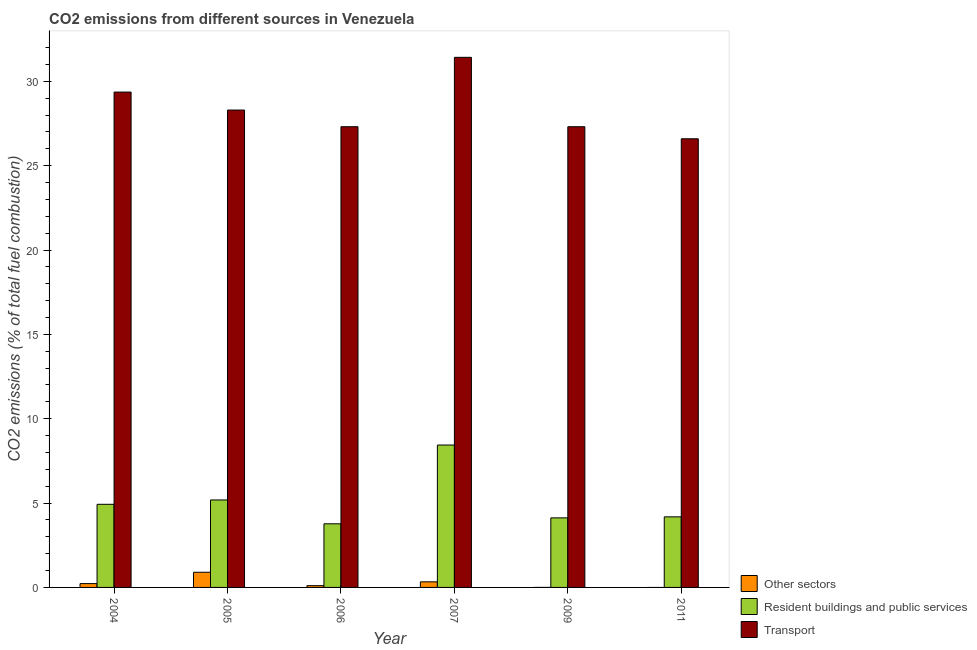How many different coloured bars are there?
Your answer should be compact. 3. How many groups of bars are there?
Offer a terse response. 6. Are the number of bars per tick equal to the number of legend labels?
Your answer should be compact. No. How many bars are there on the 6th tick from the left?
Ensure brevity in your answer.  2. How many bars are there on the 3rd tick from the right?
Make the answer very short. 3. What is the label of the 4th group of bars from the left?
Offer a very short reply. 2007. What is the percentage of co2 emissions from transport in 2004?
Keep it short and to the point. 29.36. Across all years, what is the maximum percentage of co2 emissions from resident buildings and public services?
Offer a very short reply. 8.44. Across all years, what is the minimum percentage of co2 emissions from transport?
Your response must be concise. 26.59. What is the total percentage of co2 emissions from resident buildings and public services in the graph?
Provide a short and direct response. 30.63. What is the difference between the percentage of co2 emissions from resident buildings and public services in 2007 and that in 2009?
Ensure brevity in your answer.  4.32. What is the difference between the percentage of co2 emissions from transport in 2009 and the percentage of co2 emissions from other sectors in 2004?
Provide a short and direct response. -2.05. What is the average percentage of co2 emissions from transport per year?
Keep it short and to the point. 28.38. In the year 2009, what is the difference between the percentage of co2 emissions from resident buildings and public services and percentage of co2 emissions from other sectors?
Provide a short and direct response. 0. What is the ratio of the percentage of co2 emissions from resident buildings and public services in 2005 to that in 2007?
Provide a succinct answer. 0.61. Is the difference between the percentage of co2 emissions from resident buildings and public services in 2007 and 2011 greater than the difference between the percentage of co2 emissions from transport in 2007 and 2011?
Your answer should be very brief. No. What is the difference between the highest and the second highest percentage of co2 emissions from transport?
Give a very brief answer. 2.06. What is the difference between the highest and the lowest percentage of co2 emissions from transport?
Offer a terse response. 4.83. In how many years, is the percentage of co2 emissions from other sectors greater than the average percentage of co2 emissions from other sectors taken over all years?
Your response must be concise. 2. Is it the case that in every year, the sum of the percentage of co2 emissions from other sectors and percentage of co2 emissions from resident buildings and public services is greater than the percentage of co2 emissions from transport?
Your answer should be compact. No. What is the difference between two consecutive major ticks on the Y-axis?
Offer a very short reply. 5. Does the graph contain grids?
Your answer should be very brief. No. Where does the legend appear in the graph?
Give a very brief answer. Bottom right. What is the title of the graph?
Give a very brief answer. CO2 emissions from different sources in Venezuela. Does "Unpaid family workers" appear as one of the legend labels in the graph?
Make the answer very short. No. What is the label or title of the X-axis?
Your response must be concise. Year. What is the label or title of the Y-axis?
Offer a very short reply. CO2 emissions (% of total fuel combustion). What is the CO2 emissions (% of total fuel combustion) in Other sectors in 2004?
Your answer should be very brief. 0.23. What is the CO2 emissions (% of total fuel combustion) of Resident buildings and public services in 2004?
Offer a very short reply. 4.93. What is the CO2 emissions (% of total fuel combustion) in Transport in 2004?
Offer a terse response. 29.36. What is the CO2 emissions (% of total fuel combustion) in Other sectors in 2005?
Your answer should be compact. 0.9. What is the CO2 emissions (% of total fuel combustion) in Resident buildings and public services in 2005?
Your answer should be compact. 5.18. What is the CO2 emissions (% of total fuel combustion) in Transport in 2005?
Keep it short and to the point. 28.3. What is the CO2 emissions (% of total fuel combustion) of Other sectors in 2006?
Your answer should be compact. 0.1. What is the CO2 emissions (% of total fuel combustion) of Resident buildings and public services in 2006?
Give a very brief answer. 3.77. What is the CO2 emissions (% of total fuel combustion) in Transport in 2006?
Provide a short and direct response. 27.31. What is the CO2 emissions (% of total fuel combustion) in Other sectors in 2007?
Provide a succinct answer. 0.33. What is the CO2 emissions (% of total fuel combustion) in Resident buildings and public services in 2007?
Provide a succinct answer. 8.44. What is the CO2 emissions (% of total fuel combustion) in Transport in 2007?
Your response must be concise. 31.42. What is the CO2 emissions (% of total fuel combustion) in Resident buildings and public services in 2009?
Give a very brief answer. 4.12. What is the CO2 emissions (% of total fuel combustion) of Transport in 2009?
Provide a succinct answer. 27.31. What is the CO2 emissions (% of total fuel combustion) in Other sectors in 2011?
Provide a short and direct response. 0. What is the CO2 emissions (% of total fuel combustion) in Resident buildings and public services in 2011?
Give a very brief answer. 4.18. What is the CO2 emissions (% of total fuel combustion) of Transport in 2011?
Keep it short and to the point. 26.59. Across all years, what is the maximum CO2 emissions (% of total fuel combustion) of Other sectors?
Give a very brief answer. 0.9. Across all years, what is the maximum CO2 emissions (% of total fuel combustion) in Resident buildings and public services?
Your answer should be very brief. 8.44. Across all years, what is the maximum CO2 emissions (% of total fuel combustion) of Transport?
Ensure brevity in your answer.  31.42. Across all years, what is the minimum CO2 emissions (% of total fuel combustion) in Resident buildings and public services?
Make the answer very short. 3.77. Across all years, what is the minimum CO2 emissions (% of total fuel combustion) of Transport?
Offer a terse response. 26.59. What is the total CO2 emissions (% of total fuel combustion) in Other sectors in the graph?
Your response must be concise. 1.56. What is the total CO2 emissions (% of total fuel combustion) of Resident buildings and public services in the graph?
Your response must be concise. 30.63. What is the total CO2 emissions (% of total fuel combustion) in Transport in the graph?
Keep it short and to the point. 170.29. What is the difference between the CO2 emissions (% of total fuel combustion) of Other sectors in 2004 and that in 2005?
Your answer should be very brief. -0.67. What is the difference between the CO2 emissions (% of total fuel combustion) in Resident buildings and public services in 2004 and that in 2005?
Your response must be concise. -0.26. What is the difference between the CO2 emissions (% of total fuel combustion) of Transport in 2004 and that in 2005?
Provide a succinct answer. 1.07. What is the difference between the CO2 emissions (% of total fuel combustion) in Other sectors in 2004 and that in 2006?
Make the answer very short. 0.12. What is the difference between the CO2 emissions (% of total fuel combustion) of Resident buildings and public services in 2004 and that in 2006?
Provide a succinct answer. 1.16. What is the difference between the CO2 emissions (% of total fuel combustion) of Transport in 2004 and that in 2006?
Provide a short and direct response. 2.05. What is the difference between the CO2 emissions (% of total fuel combustion) in Other sectors in 2004 and that in 2007?
Keep it short and to the point. -0.1. What is the difference between the CO2 emissions (% of total fuel combustion) of Resident buildings and public services in 2004 and that in 2007?
Offer a very short reply. -3.51. What is the difference between the CO2 emissions (% of total fuel combustion) of Transport in 2004 and that in 2007?
Ensure brevity in your answer.  -2.06. What is the difference between the CO2 emissions (% of total fuel combustion) in Resident buildings and public services in 2004 and that in 2009?
Your answer should be very brief. 0.8. What is the difference between the CO2 emissions (% of total fuel combustion) of Transport in 2004 and that in 2009?
Make the answer very short. 2.05. What is the difference between the CO2 emissions (% of total fuel combustion) of Resident buildings and public services in 2004 and that in 2011?
Offer a very short reply. 0.74. What is the difference between the CO2 emissions (% of total fuel combustion) of Transport in 2004 and that in 2011?
Your answer should be compact. 2.77. What is the difference between the CO2 emissions (% of total fuel combustion) in Other sectors in 2005 and that in 2006?
Provide a succinct answer. 0.8. What is the difference between the CO2 emissions (% of total fuel combustion) in Resident buildings and public services in 2005 and that in 2006?
Offer a terse response. 1.41. What is the difference between the CO2 emissions (% of total fuel combustion) in Transport in 2005 and that in 2006?
Provide a short and direct response. 0.99. What is the difference between the CO2 emissions (% of total fuel combustion) of Other sectors in 2005 and that in 2007?
Offer a very short reply. 0.57. What is the difference between the CO2 emissions (% of total fuel combustion) in Resident buildings and public services in 2005 and that in 2007?
Your answer should be compact. -3.26. What is the difference between the CO2 emissions (% of total fuel combustion) of Transport in 2005 and that in 2007?
Offer a very short reply. -3.13. What is the difference between the CO2 emissions (% of total fuel combustion) in Resident buildings and public services in 2005 and that in 2009?
Provide a short and direct response. 1.06. What is the difference between the CO2 emissions (% of total fuel combustion) in Transport in 2005 and that in 2009?
Your answer should be compact. 0.99. What is the difference between the CO2 emissions (% of total fuel combustion) in Transport in 2005 and that in 2011?
Provide a short and direct response. 1.7. What is the difference between the CO2 emissions (% of total fuel combustion) in Other sectors in 2006 and that in 2007?
Keep it short and to the point. -0.23. What is the difference between the CO2 emissions (% of total fuel combustion) of Resident buildings and public services in 2006 and that in 2007?
Ensure brevity in your answer.  -4.67. What is the difference between the CO2 emissions (% of total fuel combustion) in Transport in 2006 and that in 2007?
Make the answer very short. -4.11. What is the difference between the CO2 emissions (% of total fuel combustion) in Resident buildings and public services in 2006 and that in 2009?
Offer a terse response. -0.35. What is the difference between the CO2 emissions (% of total fuel combustion) of Transport in 2006 and that in 2009?
Offer a terse response. 0. What is the difference between the CO2 emissions (% of total fuel combustion) of Resident buildings and public services in 2006 and that in 2011?
Your answer should be compact. -0.41. What is the difference between the CO2 emissions (% of total fuel combustion) in Transport in 2006 and that in 2011?
Give a very brief answer. 0.71. What is the difference between the CO2 emissions (% of total fuel combustion) in Resident buildings and public services in 2007 and that in 2009?
Provide a succinct answer. 4.32. What is the difference between the CO2 emissions (% of total fuel combustion) of Transport in 2007 and that in 2009?
Offer a very short reply. 4.11. What is the difference between the CO2 emissions (% of total fuel combustion) of Resident buildings and public services in 2007 and that in 2011?
Give a very brief answer. 4.26. What is the difference between the CO2 emissions (% of total fuel combustion) in Transport in 2007 and that in 2011?
Offer a very short reply. 4.83. What is the difference between the CO2 emissions (% of total fuel combustion) of Resident buildings and public services in 2009 and that in 2011?
Offer a very short reply. -0.06. What is the difference between the CO2 emissions (% of total fuel combustion) of Transport in 2009 and that in 2011?
Provide a succinct answer. 0.71. What is the difference between the CO2 emissions (% of total fuel combustion) in Other sectors in 2004 and the CO2 emissions (% of total fuel combustion) in Resident buildings and public services in 2005?
Ensure brevity in your answer.  -4.96. What is the difference between the CO2 emissions (% of total fuel combustion) of Other sectors in 2004 and the CO2 emissions (% of total fuel combustion) of Transport in 2005?
Your answer should be very brief. -28.07. What is the difference between the CO2 emissions (% of total fuel combustion) of Resident buildings and public services in 2004 and the CO2 emissions (% of total fuel combustion) of Transport in 2005?
Offer a terse response. -23.37. What is the difference between the CO2 emissions (% of total fuel combustion) in Other sectors in 2004 and the CO2 emissions (% of total fuel combustion) in Resident buildings and public services in 2006?
Offer a terse response. -3.54. What is the difference between the CO2 emissions (% of total fuel combustion) in Other sectors in 2004 and the CO2 emissions (% of total fuel combustion) in Transport in 2006?
Provide a short and direct response. -27.08. What is the difference between the CO2 emissions (% of total fuel combustion) in Resident buildings and public services in 2004 and the CO2 emissions (% of total fuel combustion) in Transport in 2006?
Your response must be concise. -22.38. What is the difference between the CO2 emissions (% of total fuel combustion) of Other sectors in 2004 and the CO2 emissions (% of total fuel combustion) of Resident buildings and public services in 2007?
Ensure brevity in your answer.  -8.21. What is the difference between the CO2 emissions (% of total fuel combustion) of Other sectors in 2004 and the CO2 emissions (% of total fuel combustion) of Transport in 2007?
Keep it short and to the point. -31.19. What is the difference between the CO2 emissions (% of total fuel combustion) in Resident buildings and public services in 2004 and the CO2 emissions (% of total fuel combustion) in Transport in 2007?
Your answer should be very brief. -26.49. What is the difference between the CO2 emissions (% of total fuel combustion) of Other sectors in 2004 and the CO2 emissions (% of total fuel combustion) of Resident buildings and public services in 2009?
Your answer should be compact. -3.9. What is the difference between the CO2 emissions (% of total fuel combustion) in Other sectors in 2004 and the CO2 emissions (% of total fuel combustion) in Transport in 2009?
Make the answer very short. -27.08. What is the difference between the CO2 emissions (% of total fuel combustion) of Resident buildings and public services in 2004 and the CO2 emissions (% of total fuel combustion) of Transport in 2009?
Your answer should be compact. -22.38. What is the difference between the CO2 emissions (% of total fuel combustion) of Other sectors in 2004 and the CO2 emissions (% of total fuel combustion) of Resident buildings and public services in 2011?
Provide a succinct answer. -3.96. What is the difference between the CO2 emissions (% of total fuel combustion) in Other sectors in 2004 and the CO2 emissions (% of total fuel combustion) in Transport in 2011?
Give a very brief answer. -26.37. What is the difference between the CO2 emissions (% of total fuel combustion) in Resident buildings and public services in 2004 and the CO2 emissions (% of total fuel combustion) in Transport in 2011?
Provide a short and direct response. -21.67. What is the difference between the CO2 emissions (% of total fuel combustion) of Other sectors in 2005 and the CO2 emissions (% of total fuel combustion) of Resident buildings and public services in 2006?
Ensure brevity in your answer.  -2.87. What is the difference between the CO2 emissions (% of total fuel combustion) of Other sectors in 2005 and the CO2 emissions (% of total fuel combustion) of Transport in 2006?
Provide a short and direct response. -26.41. What is the difference between the CO2 emissions (% of total fuel combustion) of Resident buildings and public services in 2005 and the CO2 emissions (% of total fuel combustion) of Transport in 2006?
Your answer should be compact. -22.12. What is the difference between the CO2 emissions (% of total fuel combustion) of Other sectors in 2005 and the CO2 emissions (% of total fuel combustion) of Resident buildings and public services in 2007?
Your answer should be very brief. -7.54. What is the difference between the CO2 emissions (% of total fuel combustion) of Other sectors in 2005 and the CO2 emissions (% of total fuel combustion) of Transport in 2007?
Your answer should be very brief. -30.52. What is the difference between the CO2 emissions (% of total fuel combustion) of Resident buildings and public services in 2005 and the CO2 emissions (% of total fuel combustion) of Transport in 2007?
Make the answer very short. -26.24. What is the difference between the CO2 emissions (% of total fuel combustion) in Other sectors in 2005 and the CO2 emissions (% of total fuel combustion) in Resident buildings and public services in 2009?
Offer a very short reply. -3.22. What is the difference between the CO2 emissions (% of total fuel combustion) of Other sectors in 2005 and the CO2 emissions (% of total fuel combustion) of Transport in 2009?
Offer a very short reply. -26.41. What is the difference between the CO2 emissions (% of total fuel combustion) in Resident buildings and public services in 2005 and the CO2 emissions (% of total fuel combustion) in Transport in 2009?
Provide a succinct answer. -22.12. What is the difference between the CO2 emissions (% of total fuel combustion) of Other sectors in 2005 and the CO2 emissions (% of total fuel combustion) of Resident buildings and public services in 2011?
Provide a short and direct response. -3.28. What is the difference between the CO2 emissions (% of total fuel combustion) of Other sectors in 2005 and the CO2 emissions (% of total fuel combustion) of Transport in 2011?
Your answer should be very brief. -25.69. What is the difference between the CO2 emissions (% of total fuel combustion) in Resident buildings and public services in 2005 and the CO2 emissions (% of total fuel combustion) in Transport in 2011?
Offer a terse response. -21.41. What is the difference between the CO2 emissions (% of total fuel combustion) in Other sectors in 2006 and the CO2 emissions (% of total fuel combustion) in Resident buildings and public services in 2007?
Your response must be concise. -8.34. What is the difference between the CO2 emissions (% of total fuel combustion) in Other sectors in 2006 and the CO2 emissions (% of total fuel combustion) in Transport in 2007?
Your answer should be very brief. -31.32. What is the difference between the CO2 emissions (% of total fuel combustion) of Resident buildings and public services in 2006 and the CO2 emissions (% of total fuel combustion) of Transport in 2007?
Your answer should be very brief. -27.65. What is the difference between the CO2 emissions (% of total fuel combustion) in Other sectors in 2006 and the CO2 emissions (% of total fuel combustion) in Resident buildings and public services in 2009?
Provide a short and direct response. -4.02. What is the difference between the CO2 emissions (% of total fuel combustion) of Other sectors in 2006 and the CO2 emissions (% of total fuel combustion) of Transport in 2009?
Keep it short and to the point. -27.2. What is the difference between the CO2 emissions (% of total fuel combustion) of Resident buildings and public services in 2006 and the CO2 emissions (% of total fuel combustion) of Transport in 2009?
Offer a terse response. -23.54. What is the difference between the CO2 emissions (% of total fuel combustion) of Other sectors in 2006 and the CO2 emissions (% of total fuel combustion) of Resident buildings and public services in 2011?
Keep it short and to the point. -4.08. What is the difference between the CO2 emissions (% of total fuel combustion) in Other sectors in 2006 and the CO2 emissions (% of total fuel combustion) in Transport in 2011?
Give a very brief answer. -26.49. What is the difference between the CO2 emissions (% of total fuel combustion) of Resident buildings and public services in 2006 and the CO2 emissions (% of total fuel combustion) of Transport in 2011?
Offer a terse response. -22.82. What is the difference between the CO2 emissions (% of total fuel combustion) in Other sectors in 2007 and the CO2 emissions (% of total fuel combustion) in Resident buildings and public services in 2009?
Make the answer very short. -3.79. What is the difference between the CO2 emissions (% of total fuel combustion) of Other sectors in 2007 and the CO2 emissions (% of total fuel combustion) of Transport in 2009?
Your answer should be compact. -26.98. What is the difference between the CO2 emissions (% of total fuel combustion) in Resident buildings and public services in 2007 and the CO2 emissions (% of total fuel combustion) in Transport in 2009?
Your answer should be very brief. -18.87. What is the difference between the CO2 emissions (% of total fuel combustion) of Other sectors in 2007 and the CO2 emissions (% of total fuel combustion) of Resident buildings and public services in 2011?
Keep it short and to the point. -3.85. What is the difference between the CO2 emissions (% of total fuel combustion) of Other sectors in 2007 and the CO2 emissions (% of total fuel combustion) of Transport in 2011?
Provide a succinct answer. -26.26. What is the difference between the CO2 emissions (% of total fuel combustion) in Resident buildings and public services in 2007 and the CO2 emissions (% of total fuel combustion) in Transport in 2011?
Make the answer very short. -18.15. What is the difference between the CO2 emissions (% of total fuel combustion) of Resident buildings and public services in 2009 and the CO2 emissions (% of total fuel combustion) of Transport in 2011?
Ensure brevity in your answer.  -22.47. What is the average CO2 emissions (% of total fuel combustion) of Other sectors per year?
Your answer should be very brief. 0.26. What is the average CO2 emissions (% of total fuel combustion) of Resident buildings and public services per year?
Offer a terse response. 5.11. What is the average CO2 emissions (% of total fuel combustion) of Transport per year?
Give a very brief answer. 28.38. In the year 2004, what is the difference between the CO2 emissions (% of total fuel combustion) in Other sectors and CO2 emissions (% of total fuel combustion) in Resident buildings and public services?
Provide a short and direct response. -4.7. In the year 2004, what is the difference between the CO2 emissions (% of total fuel combustion) of Other sectors and CO2 emissions (% of total fuel combustion) of Transport?
Ensure brevity in your answer.  -29.13. In the year 2004, what is the difference between the CO2 emissions (% of total fuel combustion) in Resident buildings and public services and CO2 emissions (% of total fuel combustion) in Transport?
Ensure brevity in your answer.  -24.43. In the year 2005, what is the difference between the CO2 emissions (% of total fuel combustion) in Other sectors and CO2 emissions (% of total fuel combustion) in Resident buildings and public services?
Your answer should be very brief. -4.29. In the year 2005, what is the difference between the CO2 emissions (% of total fuel combustion) in Other sectors and CO2 emissions (% of total fuel combustion) in Transport?
Your answer should be compact. -27.4. In the year 2005, what is the difference between the CO2 emissions (% of total fuel combustion) in Resident buildings and public services and CO2 emissions (% of total fuel combustion) in Transport?
Give a very brief answer. -23.11. In the year 2006, what is the difference between the CO2 emissions (% of total fuel combustion) in Other sectors and CO2 emissions (% of total fuel combustion) in Resident buildings and public services?
Provide a short and direct response. -3.67. In the year 2006, what is the difference between the CO2 emissions (% of total fuel combustion) of Other sectors and CO2 emissions (% of total fuel combustion) of Transport?
Provide a succinct answer. -27.2. In the year 2006, what is the difference between the CO2 emissions (% of total fuel combustion) of Resident buildings and public services and CO2 emissions (% of total fuel combustion) of Transport?
Give a very brief answer. -23.54. In the year 2007, what is the difference between the CO2 emissions (% of total fuel combustion) of Other sectors and CO2 emissions (% of total fuel combustion) of Resident buildings and public services?
Offer a terse response. -8.11. In the year 2007, what is the difference between the CO2 emissions (% of total fuel combustion) of Other sectors and CO2 emissions (% of total fuel combustion) of Transport?
Ensure brevity in your answer.  -31.09. In the year 2007, what is the difference between the CO2 emissions (% of total fuel combustion) in Resident buildings and public services and CO2 emissions (% of total fuel combustion) in Transport?
Your answer should be compact. -22.98. In the year 2009, what is the difference between the CO2 emissions (% of total fuel combustion) of Resident buildings and public services and CO2 emissions (% of total fuel combustion) of Transport?
Provide a short and direct response. -23.18. In the year 2011, what is the difference between the CO2 emissions (% of total fuel combustion) in Resident buildings and public services and CO2 emissions (% of total fuel combustion) in Transport?
Provide a succinct answer. -22.41. What is the ratio of the CO2 emissions (% of total fuel combustion) of Other sectors in 2004 to that in 2005?
Offer a terse response. 0.25. What is the ratio of the CO2 emissions (% of total fuel combustion) in Resident buildings and public services in 2004 to that in 2005?
Make the answer very short. 0.95. What is the ratio of the CO2 emissions (% of total fuel combustion) in Transport in 2004 to that in 2005?
Your response must be concise. 1.04. What is the ratio of the CO2 emissions (% of total fuel combustion) in Other sectors in 2004 to that in 2006?
Offer a terse response. 2.18. What is the ratio of the CO2 emissions (% of total fuel combustion) of Resident buildings and public services in 2004 to that in 2006?
Make the answer very short. 1.31. What is the ratio of the CO2 emissions (% of total fuel combustion) of Transport in 2004 to that in 2006?
Your response must be concise. 1.08. What is the ratio of the CO2 emissions (% of total fuel combustion) in Other sectors in 2004 to that in 2007?
Provide a succinct answer. 0.68. What is the ratio of the CO2 emissions (% of total fuel combustion) in Resident buildings and public services in 2004 to that in 2007?
Ensure brevity in your answer.  0.58. What is the ratio of the CO2 emissions (% of total fuel combustion) in Transport in 2004 to that in 2007?
Your answer should be very brief. 0.93. What is the ratio of the CO2 emissions (% of total fuel combustion) of Resident buildings and public services in 2004 to that in 2009?
Offer a very short reply. 1.2. What is the ratio of the CO2 emissions (% of total fuel combustion) of Transport in 2004 to that in 2009?
Provide a short and direct response. 1.08. What is the ratio of the CO2 emissions (% of total fuel combustion) in Resident buildings and public services in 2004 to that in 2011?
Ensure brevity in your answer.  1.18. What is the ratio of the CO2 emissions (% of total fuel combustion) of Transport in 2004 to that in 2011?
Your answer should be compact. 1.1. What is the ratio of the CO2 emissions (% of total fuel combustion) in Other sectors in 2005 to that in 2006?
Provide a short and direct response. 8.64. What is the ratio of the CO2 emissions (% of total fuel combustion) in Resident buildings and public services in 2005 to that in 2006?
Your answer should be very brief. 1.37. What is the ratio of the CO2 emissions (% of total fuel combustion) in Transport in 2005 to that in 2006?
Provide a short and direct response. 1.04. What is the ratio of the CO2 emissions (% of total fuel combustion) of Other sectors in 2005 to that in 2007?
Your answer should be very brief. 2.71. What is the ratio of the CO2 emissions (% of total fuel combustion) of Resident buildings and public services in 2005 to that in 2007?
Keep it short and to the point. 0.61. What is the ratio of the CO2 emissions (% of total fuel combustion) in Transport in 2005 to that in 2007?
Your response must be concise. 0.9. What is the ratio of the CO2 emissions (% of total fuel combustion) of Resident buildings and public services in 2005 to that in 2009?
Offer a terse response. 1.26. What is the ratio of the CO2 emissions (% of total fuel combustion) of Transport in 2005 to that in 2009?
Your answer should be very brief. 1.04. What is the ratio of the CO2 emissions (% of total fuel combustion) in Resident buildings and public services in 2005 to that in 2011?
Offer a terse response. 1.24. What is the ratio of the CO2 emissions (% of total fuel combustion) of Transport in 2005 to that in 2011?
Give a very brief answer. 1.06. What is the ratio of the CO2 emissions (% of total fuel combustion) in Other sectors in 2006 to that in 2007?
Provide a short and direct response. 0.31. What is the ratio of the CO2 emissions (% of total fuel combustion) of Resident buildings and public services in 2006 to that in 2007?
Your response must be concise. 0.45. What is the ratio of the CO2 emissions (% of total fuel combustion) in Transport in 2006 to that in 2007?
Provide a short and direct response. 0.87. What is the ratio of the CO2 emissions (% of total fuel combustion) in Resident buildings and public services in 2006 to that in 2009?
Provide a short and direct response. 0.91. What is the ratio of the CO2 emissions (% of total fuel combustion) in Resident buildings and public services in 2006 to that in 2011?
Your answer should be compact. 0.9. What is the ratio of the CO2 emissions (% of total fuel combustion) in Transport in 2006 to that in 2011?
Provide a succinct answer. 1.03. What is the ratio of the CO2 emissions (% of total fuel combustion) in Resident buildings and public services in 2007 to that in 2009?
Offer a very short reply. 2.05. What is the ratio of the CO2 emissions (% of total fuel combustion) of Transport in 2007 to that in 2009?
Keep it short and to the point. 1.15. What is the ratio of the CO2 emissions (% of total fuel combustion) of Resident buildings and public services in 2007 to that in 2011?
Keep it short and to the point. 2.02. What is the ratio of the CO2 emissions (% of total fuel combustion) in Transport in 2007 to that in 2011?
Your answer should be compact. 1.18. What is the ratio of the CO2 emissions (% of total fuel combustion) of Resident buildings and public services in 2009 to that in 2011?
Offer a very short reply. 0.99. What is the ratio of the CO2 emissions (% of total fuel combustion) of Transport in 2009 to that in 2011?
Ensure brevity in your answer.  1.03. What is the difference between the highest and the second highest CO2 emissions (% of total fuel combustion) in Other sectors?
Keep it short and to the point. 0.57. What is the difference between the highest and the second highest CO2 emissions (% of total fuel combustion) in Resident buildings and public services?
Provide a succinct answer. 3.26. What is the difference between the highest and the second highest CO2 emissions (% of total fuel combustion) in Transport?
Keep it short and to the point. 2.06. What is the difference between the highest and the lowest CO2 emissions (% of total fuel combustion) in Other sectors?
Give a very brief answer. 0.9. What is the difference between the highest and the lowest CO2 emissions (% of total fuel combustion) in Resident buildings and public services?
Your response must be concise. 4.67. What is the difference between the highest and the lowest CO2 emissions (% of total fuel combustion) in Transport?
Make the answer very short. 4.83. 